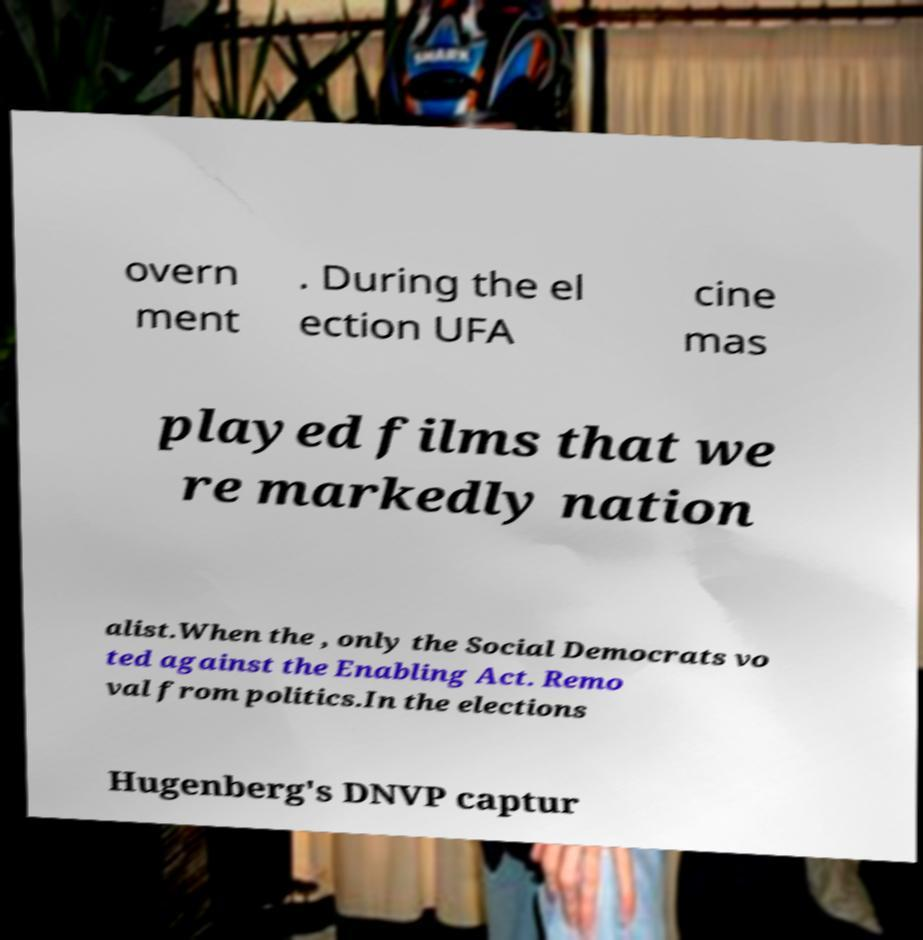Please read and relay the text visible in this image. What does it say? overn ment . During the el ection UFA cine mas played films that we re markedly nation alist.When the , only the Social Democrats vo ted against the Enabling Act. Remo val from politics.In the elections Hugenberg's DNVP captur 